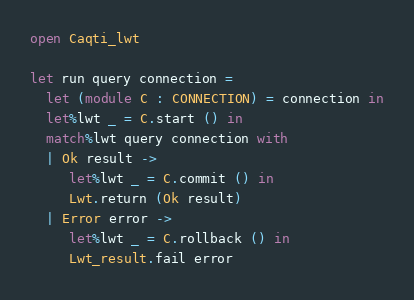<code> <loc_0><loc_0><loc_500><loc_500><_OCaml_>open Caqti_lwt

let run query connection =
  let (module C : CONNECTION) = connection in
  let%lwt _ = C.start () in
  match%lwt query connection with
  | Ok result ->
     let%lwt _ = C.commit () in
     Lwt.return (Ok result)
  | Error error ->
     let%lwt _ = C.rollback () in
     Lwt_result.fail error
</code> 